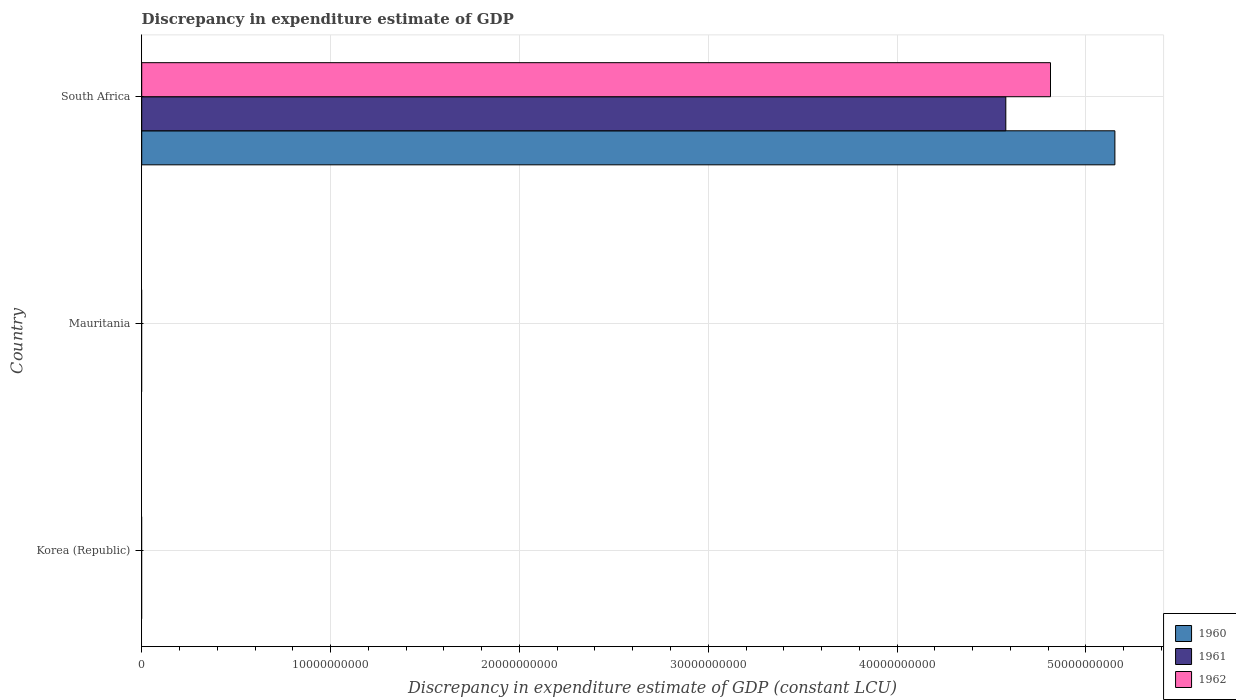Are the number of bars per tick equal to the number of legend labels?
Your answer should be very brief. No. Are the number of bars on each tick of the Y-axis equal?
Your answer should be compact. No. How many bars are there on the 3rd tick from the top?
Provide a short and direct response. 0. How many bars are there on the 2nd tick from the bottom?
Make the answer very short. 0. What is the label of the 2nd group of bars from the top?
Your answer should be compact. Mauritania. In how many cases, is the number of bars for a given country not equal to the number of legend labels?
Ensure brevity in your answer.  2. What is the discrepancy in expenditure estimate of GDP in 1961 in South Africa?
Make the answer very short. 4.58e+1. Across all countries, what is the maximum discrepancy in expenditure estimate of GDP in 1962?
Your response must be concise. 4.81e+1. Across all countries, what is the minimum discrepancy in expenditure estimate of GDP in 1962?
Ensure brevity in your answer.  0. In which country was the discrepancy in expenditure estimate of GDP in 1961 maximum?
Ensure brevity in your answer.  South Africa. What is the total discrepancy in expenditure estimate of GDP in 1960 in the graph?
Offer a terse response. 5.15e+1. What is the difference between the discrepancy in expenditure estimate of GDP in 1960 in South Africa and the discrepancy in expenditure estimate of GDP in 1961 in Mauritania?
Give a very brief answer. 5.15e+1. What is the average discrepancy in expenditure estimate of GDP in 1960 per country?
Your answer should be very brief. 1.72e+1. What is the difference between the discrepancy in expenditure estimate of GDP in 1961 and discrepancy in expenditure estimate of GDP in 1962 in South Africa?
Your response must be concise. -2.37e+09. In how many countries, is the discrepancy in expenditure estimate of GDP in 1960 greater than 24000000000 LCU?
Your answer should be very brief. 1. What is the difference between the highest and the lowest discrepancy in expenditure estimate of GDP in 1960?
Offer a very short reply. 5.15e+1. Are all the bars in the graph horizontal?
Provide a succinct answer. Yes. How many countries are there in the graph?
Your response must be concise. 3. Are the values on the major ticks of X-axis written in scientific E-notation?
Your response must be concise. No. Does the graph contain any zero values?
Your response must be concise. Yes. Does the graph contain grids?
Ensure brevity in your answer.  Yes. Where does the legend appear in the graph?
Give a very brief answer. Bottom right. How are the legend labels stacked?
Offer a very short reply. Vertical. What is the title of the graph?
Offer a terse response. Discrepancy in expenditure estimate of GDP. What is the label or title of the X-axis?
Keep it short and to the point. Discrepancy in expenditure estimate of GDP (constant LCU). What is the label or title of the Y-axis?
Your response must be concise. Country. What is the Discrepancy in expenditure estimate of GDP (constant LCU) of 1960 in Korea (Republic)?
Your response must be concise. 0. What is the Discrepancy in expenditure estimate of GDP (constant LCU) in 1961 in Korea (Republic)?
Provide a succinct answer. 0. What is the Discrepancy in expenditure estimate of GDP (constant LCU) in 1962 in Korea (Republic)?
Offer a terse response. 0. What is the Discrepancy in expenditure estimate of GDP (constant LCU) of 1960 in Mauritania?
Offer a very short reply. 0. What is the Discrepancy in expenditure estimate of GDP (constant LCU) of 1960 in South Africa?
Give a very brief answer. 5.15e+1. What is the Discrepancy in expenditure estimate of GDP (constant LCU) in 1961 in South Africa?
Make the answer very short. 4.58e+1. What is the Discrepancy in expenditure estimate of GDP (constant LCU) of 1962 in South Africa?
Your answer should be very brief. 4.81e+1. Across all countries, what is the maximum Discrepancy in expenditure estimate of GDP (constant LCU) of 1960?
Provide a succinct answer. 5.15e+1. Across all countries, what is the maximum Discrepancy in expenditure estimate of GDP (constant LCU) of 1961?
Your response must be concise. 4.58e+1. Across all countries, what is the maximum Discrepancy in expenditure estimate of GDP (constant LCU) in 1962?
Offer a terse response. 4.81e+1. Across all countries, what is the minimum Discrepancy in expenditure estimate of GDP (constant LCU) in 1961?
Make the answer very short. 0. What is the total Discrepancy in expenditure estimate of GDP (constant LCU) of 1960 in the graph?
Provide a short and direct response. 5.15e+1. What is the total Discrepancy in expenditure estimate of GDP (constant LCU) of 1961 in the graph?
Keep it short and to the point. 4.58e+1. What is the total Discrepancy in expenditure estimate of GDP (constant LCU) in 1962 in the graph?
Offer a terse response. 4.81e+1. What is the average Discrepancy in expenditure estimate of GDP (constant LCU) of 1960 per country?
Provide a succinct answer. 1.72e+1. What is the average Discrepancy in expenditure estimate of GDP (constant LCU) in 1961 per country?
Ensure brevity in your answer.  1.53e+1. What is the average Discrepancy in expenditure estimate of GDP (constant LCU) of 1962 per country?
Give a very brief answer. 1.60e+1. What is the difference between the Discrepancy in expenditure estimate of GDP (constant LCU) in 1960 and Discrepancy in expenditure estimate of GDP (constant LCU) in 1961 in South Africa?
Ensure brevity in your answer.  5.78e+09. What is the difference between the Discrepancy in expenditure estimate of GDP (constant LCU) in 1960 and Discrepancy in expenditure estimate of GDP (constant LCU) in 1962 in South Africa?
Provide a succinct answer. 3.41e+09. What is the difference between the Discrepancy in expenditure estimate of GDP (constant LCU) in 1961 and Discrepancy in expenditure estimate of GDP (constant LCU) in 1962 in South Africa?
Offer a very short reply. -2.37e+09. What is the difference between the highest and the lowest Discrepancy in expenditure estimate of GDP (constant LCU) of 1960?
Ensure brevity in your answer.  5.15e+1. What is the difference between the highest and the lowest Discrepancy in expenditure estimate of GDP (constant LCU) in 1961?
Offer a terse response. 4.58e+1. What is the difference between the highest and the lowest Discrepancy in expenditure estimate of GDP (constant LCU) in 1962?
Make the answer very short. 4.81e+1. 